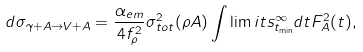<formula> <loc_0><loc_0><loc_500><loc_500>d \sigma _ { \gamma + A \to V + A } = \frac { \alpha _ { e m } } { 4 { f _ { \rho } ^ { 2 } } } { \sigma _ { t o t } ^ { 2 } } ( \rho A ) \int \lim i t s _ { t _ { \min } } ^ { \infty } d t F _ { A } ^ { 2 } ( t ) ,</formula> 